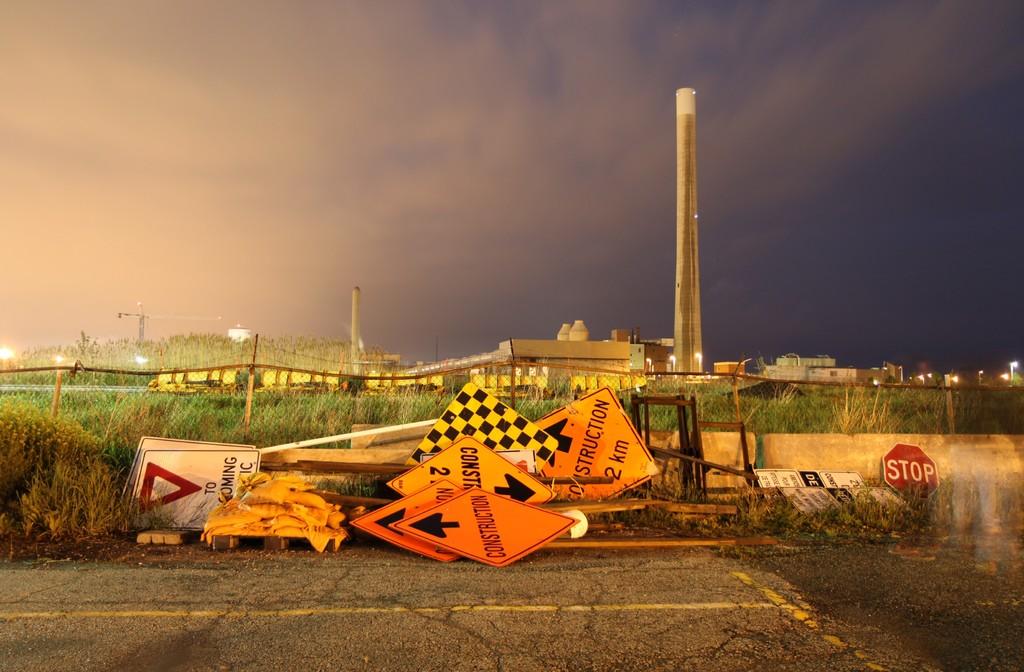What red sign is sitting up near the bottom right?
Your answer should be compact. Stop. 